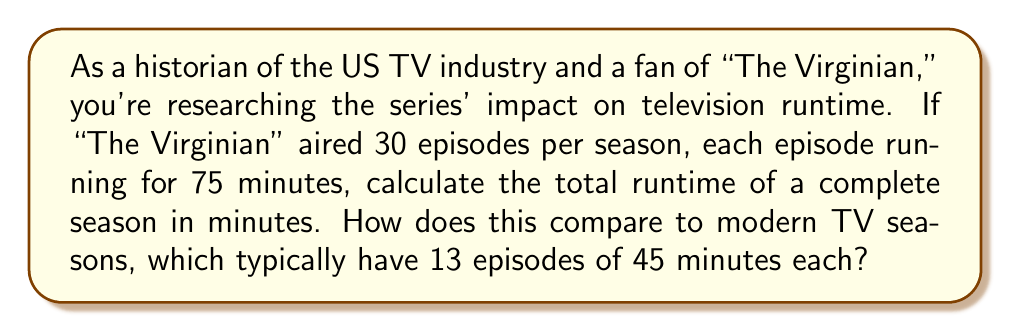Solve this math problem. To solve this problem, we'll follow these steps:

1. Calculate the total runtime of "The Virginian" season:
   $$ \text{Total runtime} = \text{Number of episodes} \times \text{Runtime per episode} $$
   $$ \text{Total runtime} = 30 \times 75 = 2250 \text{ minutes} $$

2. Calculate the total runtime of a typical modern TV season:
   $$ \text{Modern season runtime} = 13 \times 45 = 585 \text{ minutes} $$

3. Compare the two:
   $$ \text{Difference} = 2250 - 585 = 1665 \text{ minutes} $$
   
   To express this as a ratio:
   $$ \text{Ratio} = \frac{2250}{585} \approx 3.85 $$

This means that a season of "The Virginian" had about 3.85 times more content than a typical modern TV season.

To express the difference as a percentage increase:
$$ \text{Percentage increase} = \frac{2250 - 585}{585} \times 100\% \approx 284.6\% $$
Answer: A complete season of "The Virginian" had a total runtime of 2250 minutes, which is 1665 minutes more than a typical modern TV season. This represents approximately 3.85 times more content, or a 284.6% increase compared to modern seasons. 